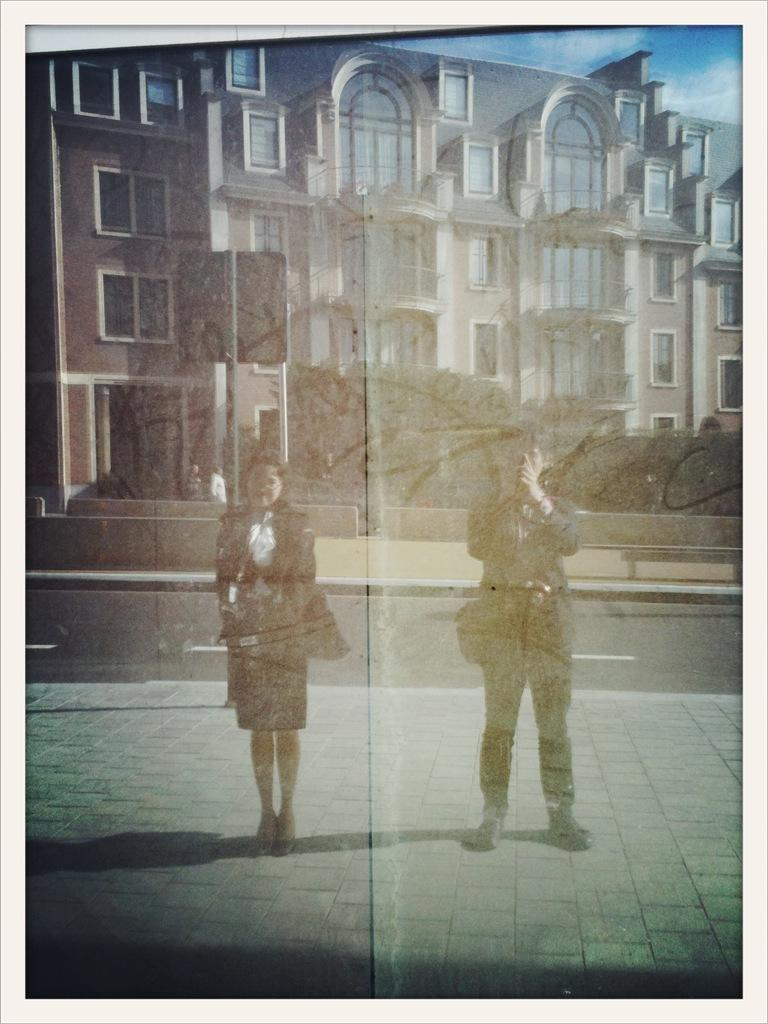How many people are present in the image? There are two people, a man and a woman, present in the image. What is the position of the man and woman in the image? Both the man and woman are on the ground in the image. What can be seen in the background of the image? There are buildings, trees, and the sky visible in the background of the image. What is the condition of the sky in the image? The sky is visible in the background of the image, and there are clouds present. What type of leather is being used to make the mist in the image? There is no mist or leather present in the image. The image features a man and a woman on the ground, with buildings, trees, and a cloudy sky in the background. 